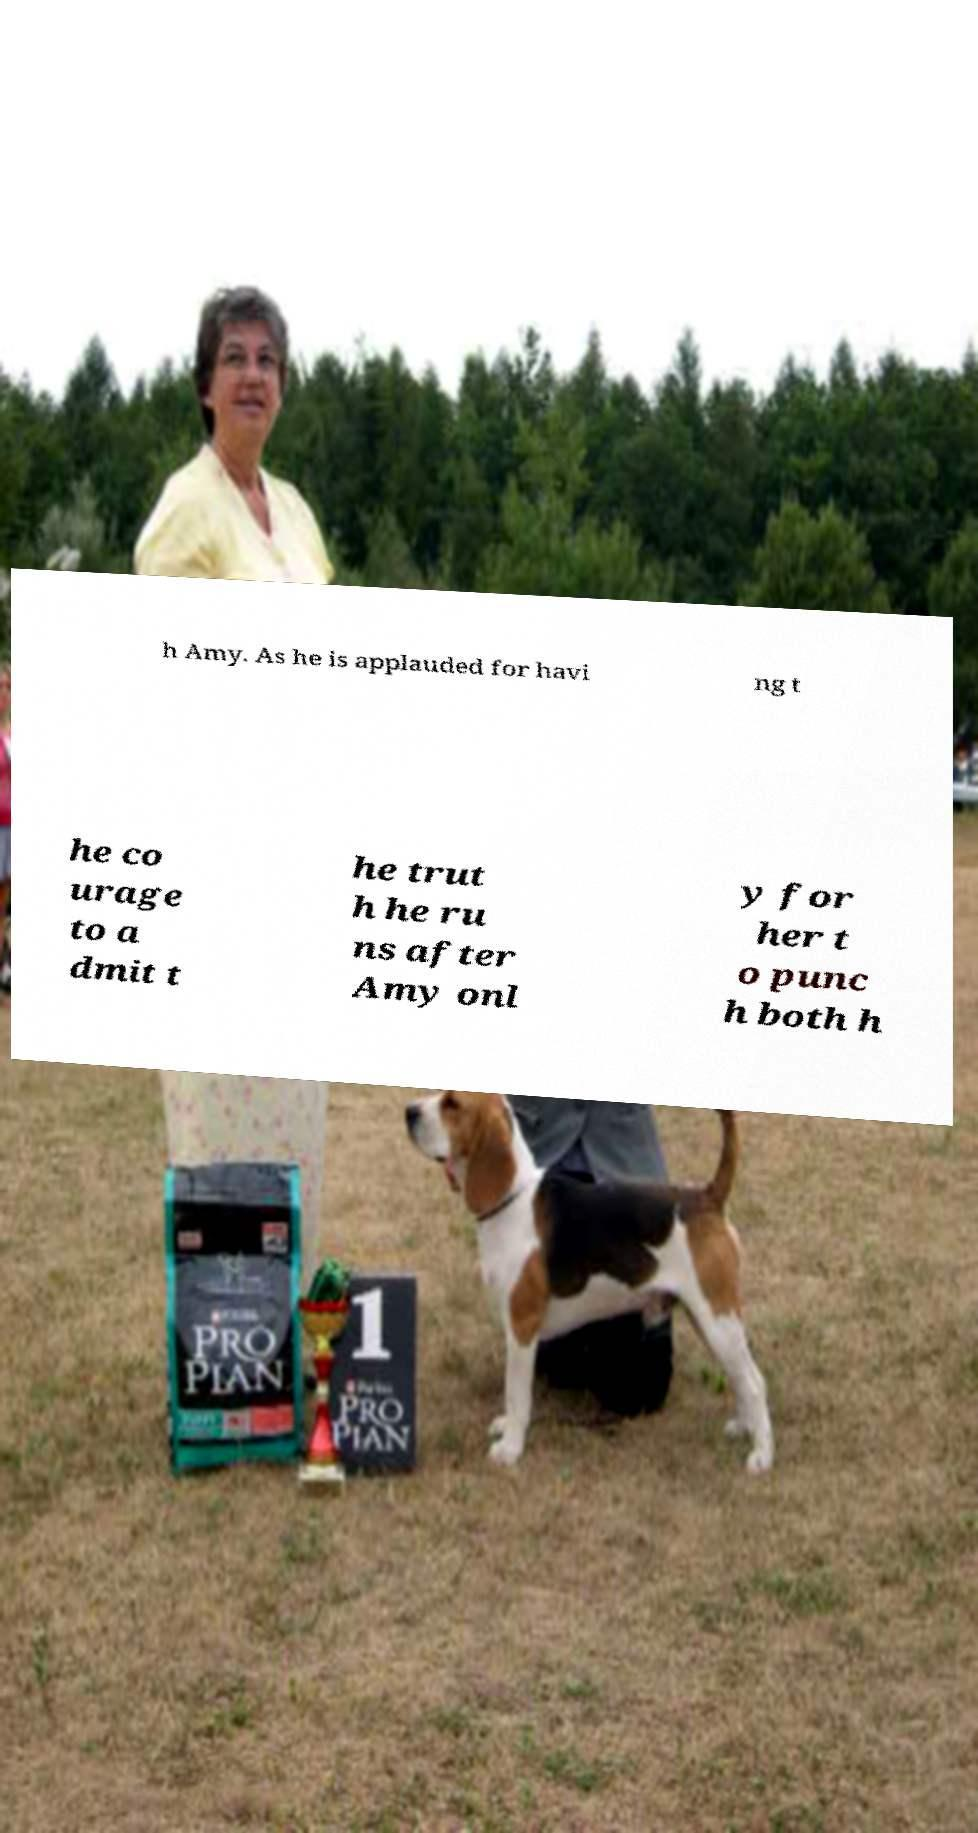Could you extract and type out the text from this image? h Amy. As he is applauded for havi ng t he co urage to a dmit t he trut h he ru ns after Amy onl y for her t o punc h both h 